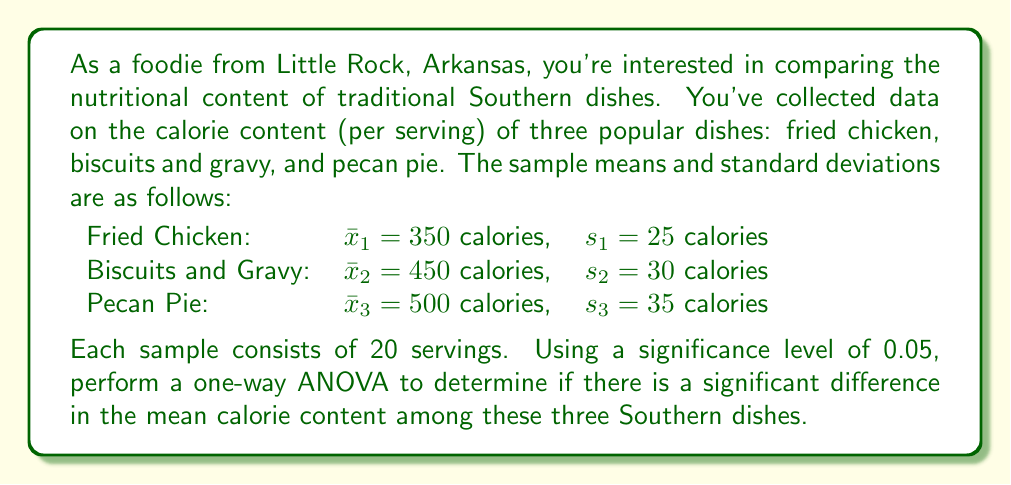Can you solve this math problem? To perform a one-way ANOVA, we'll follow these steps:

1. Calculate the sum of squares between groups (SSB):
   $$SSB = \sum_{i=1}^k n_i(\bar{x}_i - \bar{x})^2$$
   where $k$ is the number of groups, $n_i$ is the sample size of each group, $\bar{x}_i$ is the mean of each group, and $\bar{x}$ is the grand mean.

2. Calculate the sum of squares within groups (SSW):
   $$SSW = \sum_{i=1}^k (n_i - 1)s_i^2$$
   where $s_i$ is the standard deviation of each group.

3. Calculate the degrees of freedom:
   $df_{between} = k - 1 = 3 - 1 = 2$
   $df_{within} = N - k = 60 - 3 = 57$
   where $N$ is the total sample size.

4. Calculate the mean squares:
   $$MSB = \frac{SSB}{df_{between}}$$
   $$MSW = \frac{SSW}{df_{within}}$$

5. Calculate the F-statistic:
   $$F = \frac{MSB}{MSW}$$

6. Compare the F-statistic to the critical F-value.

Step 1: Calculate SSB
First, we need the grand mean:
$\bar{x} = \frac{350 + 450 + 500}{3} = 433.33$

Now, calculate SSB:
$$SSB = 20(350 - 433.33)^2 + 20(450 - 433.33)^2 + 20(500 - 433.33)^2 = 225,000$$

Step 2: Calculate SSW
$$SSW = 19(25^2) + 19(30^2) + 19(35^2) = 52,250$$

Step 3: Degrees of freedom are already calculated.

Step 4: Calculate mean squares
$$MSB = \frac{225,000}{2} = 112,500$$
$$MSW = \frac{52,250}{57} = 916.67$$

Step 5: Calculate F-statistic
$$F = \frac{112,500}{916.67} = 122.73$$

Step 6: Compare to critical F-value
The critical F-value for $\alpha = 0.05$, $df_{between} = 2$, and $df_{within} = 57$ is approximately 3.16.

Since our calculated F-statistic (122.73) is much larger than the critical F-value (3.16), we reject the null hypothesis.
Answer: Reject null hypothesis; significant difference in mean calorie content (F = 122.73, p < 0.05). 